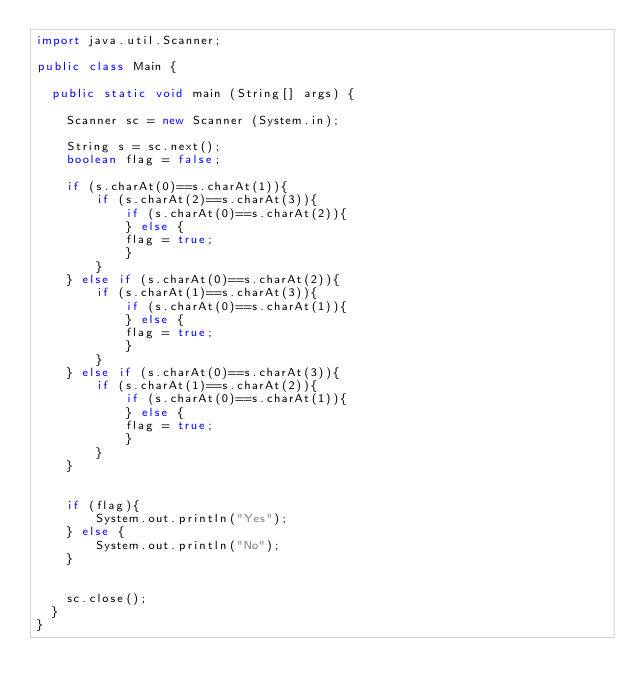<code> <loc_0><loc_0><loc_500><loc_500><_Java_>import java.util.Scanner;

public class Main {

	public static void main (String[] args) {

		Scanner sc = new Scanner (System.in);
		
		String s = sc.next();
		boolean flag = false;
		
		if (s.charAt(0)==s.charAt(1)){
		    if (s.charAt(2)==s.charAt(3)){
		        if (s.charAt(0)==s.charAt(2)){
		        } else {
		        flag = true;
		        }
		    }
		} else if (s.charAt(0)==s.charAt(2)){
		    if (s.charAt(1)==s.charAt(3)){
		        if (s.charAt(0)==s.charAt(1)){
		        } else {
		        flag = true;
		        }
		    }
		} else if (s.charAt(0)==s.charAt(3)){
		    if (s.charAt(1)==s.charAt(2)){
		        if (s.charAt(0)==s.charAt(1)){
		        } else {
		        flag = true;
		        }
		    }
		}
		
		
		if (flag){
		    System.out.println("Yes");
		} else {
		    System.out.println("No");
		}
		

		sc.close();
	}
}
</code> 